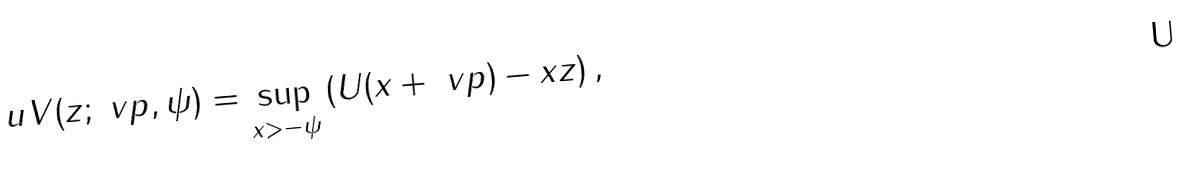<formula> <loc_0><loc_0><loc_500><loc_500>\ u V ( z ; \ v p , \psi ) = \sup _ { x > - \psi } \left ( U ( x + \ v p ) - x z \right ) ,</formula> 